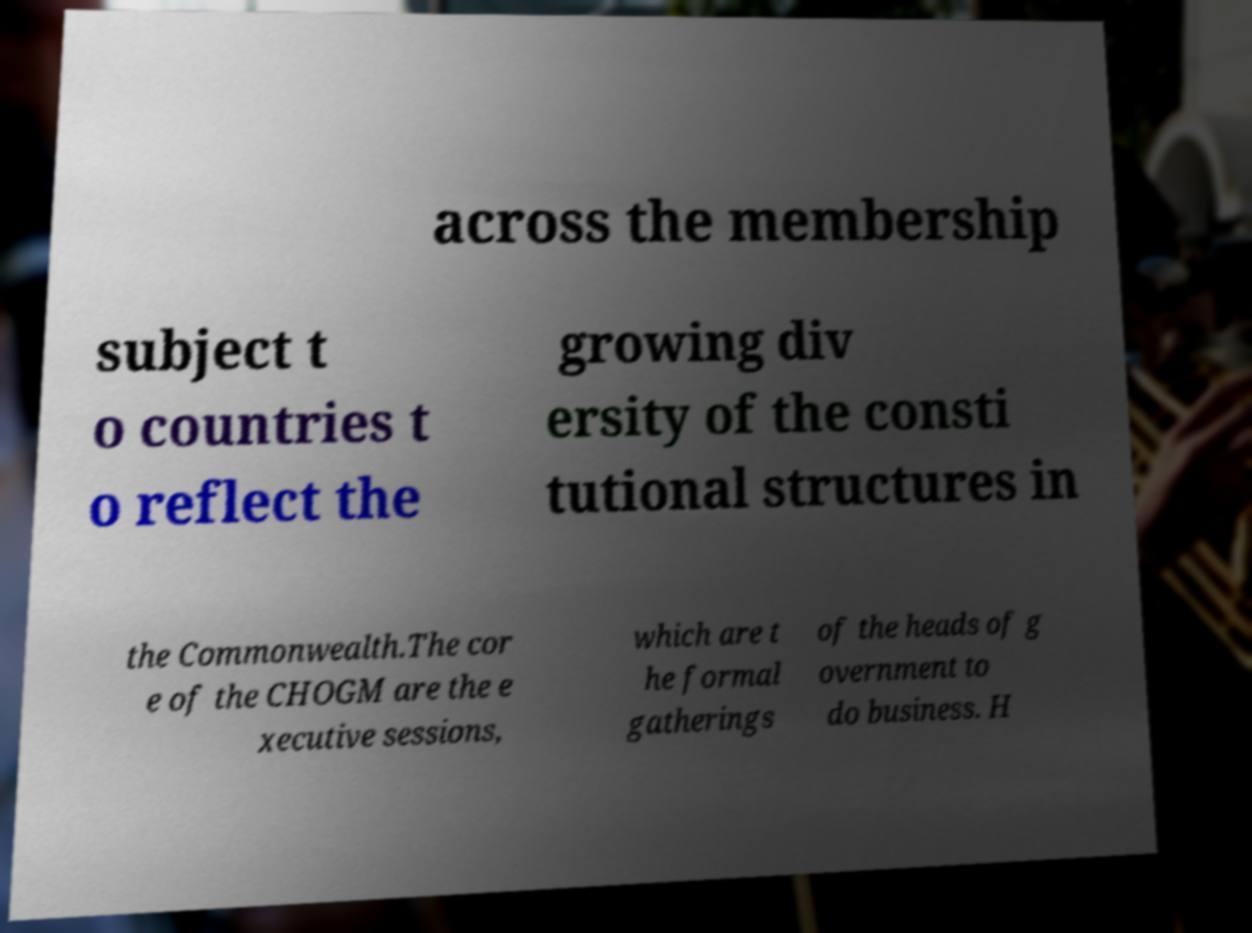Could you assist in decoding the text presented in this image and type it out clearly? across the membership subject t o countries t o reflect the growing div ersity of the consti tutional structures in the Commonwealth.The cor e of the CHOGM are the e xecutive sessions, which are t he formal gatherings of the heads of g overnment to do business. H 